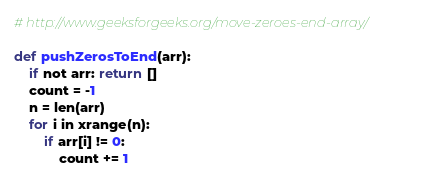<code> <loc_0><loc_0><loc_500><loc_500><_Python_># http://www.geeksforgeeks.org/move-zeroes-end-array/

def pushZerosToEnd(arr):
    if not arr: return []
    count = -1
    n = len(arr)
    for i in xrange(n):
        if arr[i] != 0:
            count += 1</code> 